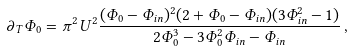<formula> <loc_0><loc_0><loc_500><loc_500>\partial _ { T } \Phi _ { 0 } = \pi ^ { 2 } U ^ { 2 } \frac { ( \Phi _ { 0 } - \Phi _ { i n } ) ^ { 2 } ( 2 + \Phi _ { 0 } - \Phi _ { i n } ) ( 3 \Phi _ { i n } ^ { 2 } - 1 ) } { 2 \Phi _ { 0 } ^ { 3 } - 3 \Phi _ { 0 } ^ { 2 } \Phi _ { i n } - \Phi _ { i n } } \, ,</formula> 